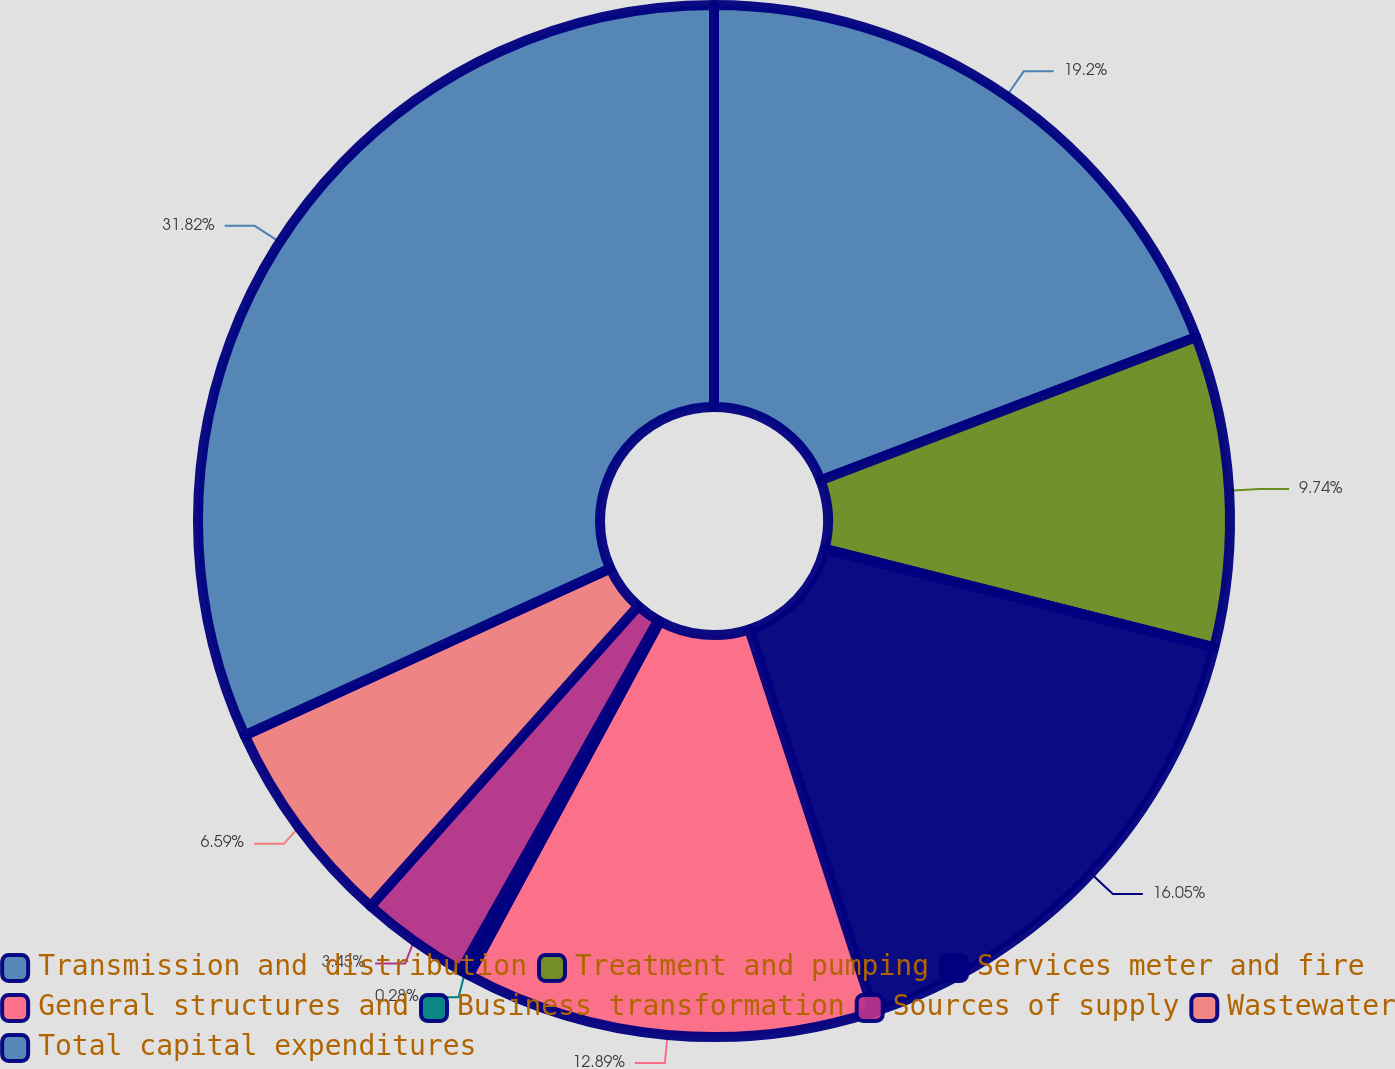Convert chart. <chart><loc_0><loc_0><loc_500><loc_500><pie_chart><fcel>Transmission and distribution<fcel>Treatment and pumping<fcel>Services meter and fire<fcel>General structures and<fcel>Business transformation<fcel>Sources of supply<fcel>Wastewater<fcel>Total capital expenditures<nl><fcel>19.2%<fcel>9.74%<fcel>16.05%<fcel>12.89%<fcel>0.28%<fcel>3.43%<fcel>6.59%<fcel>31.82%<nl></chart> 